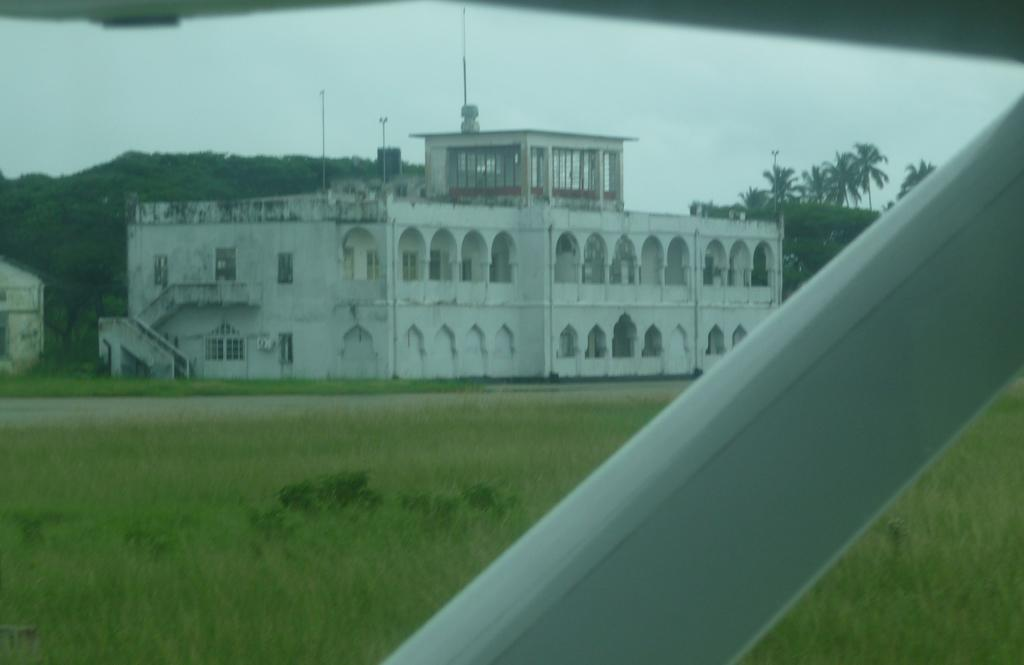What is the color of the object in the image? The object in the image is white. What type of terrain is visible at the bottom of the image? There is grassy land at the bottom of the image. What can be seen in the middle of the image? There are trees and a building in the middle of the image. What is visible in the background of the image? The sky is visible in the background of the image. How many sheep are grazing on the grassy land in the image? There are no sheep present in the image; it features a white object, trees, a building, and the sky. What type of snack is being served in the image? There is no snack, such as popcorn, present in the image. 